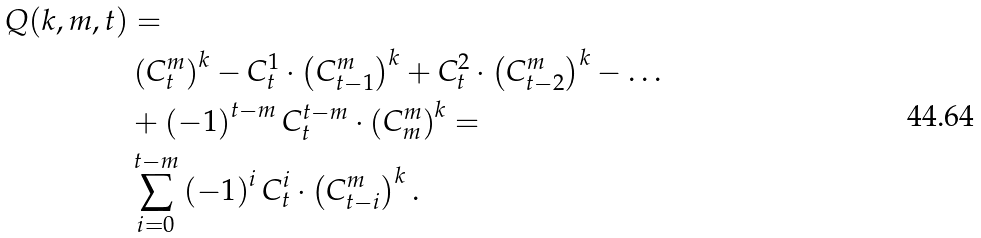<formula> <loc_0><loc_0><loc_500><loc_500>Q ( k , m , t ) & = \\ & \left ( C _ { t } ^ { m } \right ) ^ { k } - C _ { t } ^ { 1 } \cdot \left ( C _ { t - 1 } ^ { m } \right ) ^ { k } + C _ { t } ^ { 2 } \cdot \left ( C _ { t - 2 } ^ { m } \right ) ^ { k } - \dots \\ & + \left ( - 1 \right ) ^ { t - m } C _ { t } ^ { t - m } \cdot \left ( C _ { m } ^ { m } \right ) ^ { k } = \\ & \sum _ { i = 0 } ^ { t - m } \left ( - 1 \right ) ^ { i } C _ { t } ^ { i } \cdot \left ( C _ { t - i } ^ { m } \right ) ^ { k } .</formula> 